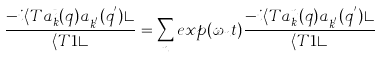Convert formula to latex. <formula><loc_0><loc_0><loc_500><loc_500>\frac { - i \langle T a ^ { t } _ { k } ( { q } ) a ^ { \dagger } _ { { k } ^ { ^ { \prime } } } ( { q } ^ { ^ { \prime } } ) \rangle } { \langle T 1 \rangle } = \sum _ { n } e x p ( \omega _ { n } t ) \frac { - i \langle T a ^ { n } _ { k } ( { q } ) a ^ { \dagger } _ { { k } ^ { ^ { \prime } } } ( { q } ^ { ^ { \prime } } ) \rangle } { \langle T 1 \rangle }</formula> 